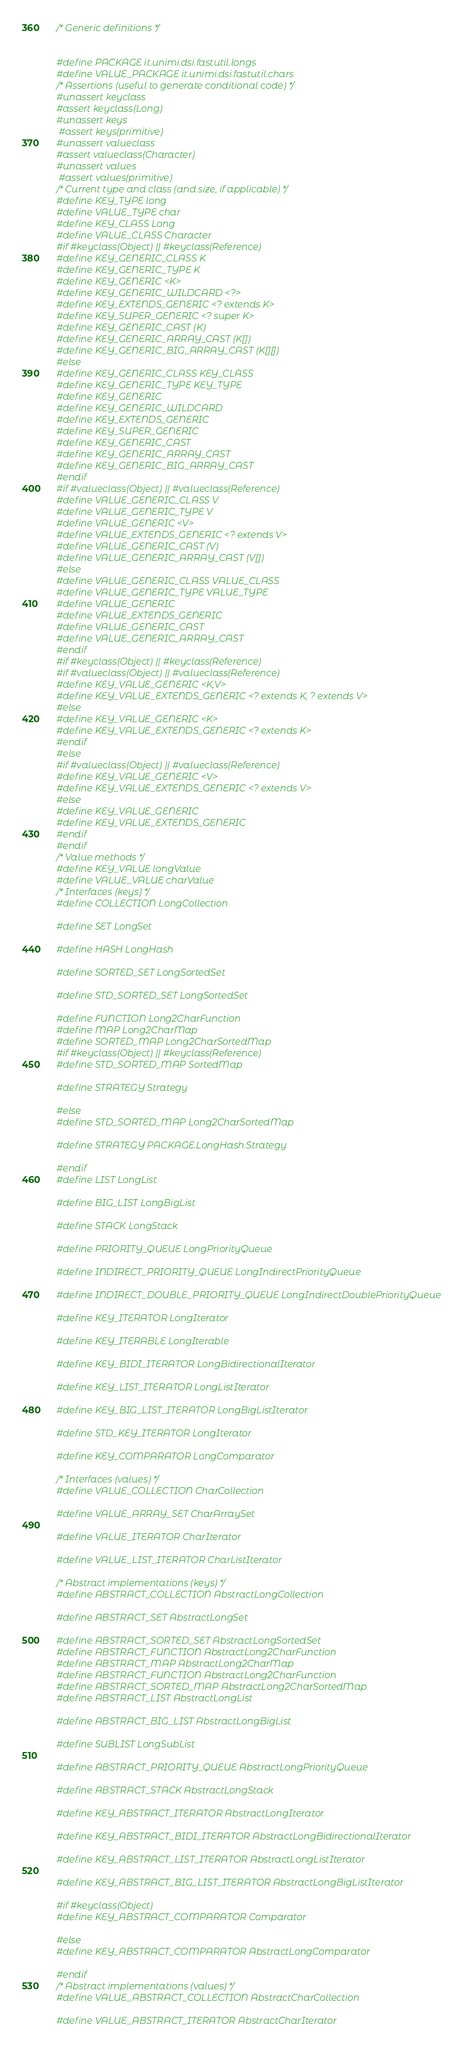<code> <loc_0><loc_0><loc_500><loc_500><_C_>/* Generic definitions */


#define PACKAGE it.unimi.dsi.fastutil.longs
#define VALUE_PACKAGE it.unimi.dsi.fastutil.chars
/* Assertions (useful to generate conditional code) */
#unassert keyclass
#assert keyclass(Long)
#unassert keys
 #assert keys(primitive)
#unassert valueclass
#assert valueclass(Character)
#unassert values
 #assert values(primitive)
/* Current type and class (and size, if applicable) */
#define KEY_TYPE long
#define VALUE_TYPE char
#define KEY_CLASS Long
#define VALUE_CLASS Character
#if #keyclass(Object) || #keyclass(Reference)
#define KEY_GENERIC_CLASS K
#define KEY_GENERIC_TYPE K
#define KEY_GENERIC <K>
#define KEY_GENERIC_WILDCARD <?>
#define KEY_EXTENDS_GENERIC <? extends K>
#define KEY_SUPER_GENERIC <? super K>
#define KEY_GENERIC_CAST (K)
#define KEY_GENERIC_ARRAY_CAST (K[])
#define KEY_GENERIC_BIG_ARRAY_CAST (K[][])
#else
#define KEY_GENERIC_CLASS KEY_CLASS
#define KEY_GENERIC_TYPE KEY_TYPE
#define KEY_GENERIC
#define KEY_GENERIC_WILDCARD
#define KEY_EXTENDS_GENERIC
#define KEY_SUPER_GENERIC
#define KEY_GENERIC_CAST
#define KEY_GENERIC_ARRAY_CAST
#define KEY_GENERIC_BIG_ARRAY_CAST
#endif
#if #valueclass(Object) || #valueclass(Reference)
#define VALUE_GENERIC_CLASS V
#define VALUE_GENERIC_TYPE V
#define VALUE_GENERIC <V>
#define VALUE_EXTENDS_GENERIC <? extends V>
#define VALUE_GENERIC_CAST (V)
#define VALUE_GENERIC_ARRAY_CAST (V[])
#else
#define VALUE_GENERIC_CLASS VALUE_CLASS
#define VALUE_GENERIC_TYPE VALUE_TYPE
#define VALUE_GENERIC
#define VALUE_EXTENDS_GENERIC
#define VALUE_GENERIC_CAST
#define VALUE_GENERIC_ARRAY_CAST
#endif
#if #keyclass(Object) || #keyclass(Reference)
#if #valueclass(Object) || #valueclass(Reference)
#define KEY_VALUE_GENERIC <K,V>
#define KEY_VALUE_EXTENDS_GENERIC <? extends K, ? extends V>
#else
#define KEY_VALUE_GENERIC <K>
#define KEY_VALUE_EXTENDS_GENERIC <? extends K>
#endif
#else
#if #valueclass(Object) || #valueclass(Reference)
#define KEY_VALUE_GENERIC <V>
#define KEY_VALUE_EXTENDS_GENERIC <? extends V>
#else
#define KEY_VALUE_GENERIC
#define KEY_VALUE_EXTENDS_GENERIC
#endif
#endif
/* Value methods */
#define KEY_VALUE longValue
#define VALUE_VALUE charValue
/* Interfaces (keys) */
#define COLLECTION LongCollection

#define SET LongSet

#define HASH LongHash

#define SORTED_SET LongSortedSet

#define STD_SORTED_SET LongSortedSet

#define FUNCTION Long2CharFunction
#define MAP Long2CharMap
#define SORTED_MAP Long2CharSortedMap
#if #keyclass(Object) || #keyclass(Reference)
#define STD_SORTED_MAP SortedMap

#define STRATEGY Strategy

#else
#define STD_SORTED_MAP Long2CharSortedMap

#define STRATEGY PACKAGE.LongHash.Strategy

#endif
#define LIST LongList

#define BIG_LIST LongBigList

#define STACK LongStack

#define PRIORITY_QUEUE LongPriorityQueue

#define INDIRECT_PRIORITY_QUEUE LongIndirectPriorityQueue

#define INDIRECT_DOUBLE_PRIORITY_QUEUE LongIndirectDoublePriorityQueue

#define KEY_ITERATOR LongIterator

#define KEY_ITERABLE LongIterable

#define KEY_BIDI_ITERATOR LongBidirectionalIterator

#define KEY_LIST_ITERATOR LongListIterator

#define KEY_BIG_LIST_ITERATOR LongBigListIterator

#define STD_KEY_ITERATOR LongIterator

#define KEY_COMPARATOR LongComparator

/* Interfaces (values) */
#define VALUE_COLLECTION CharCollection

#define VALUE_ARRAY_SET CharArraySet

#define VALUE_ITERATOR CharIterator

#define VALUE_LIST_ITERATOR CharListIterator

/* Abstract implementations (keys) */
#define ABSTRACT_COLLECTION AbstractLongCollection

#define ABSTRACT_SET AbstractLongSet

#define ABSTRACT_SORTED_SET AbstractLongSortedSet
#define ABSTRACT_FUNCTION AbstractLong2CharFunction
#define ABSTRACT_MAP AbstractLong2CharMap
#define ABSTRACT_FUNCTION AbstractLong2CharFunction
#define ABSTRACT_SORTED_MAP AbstractLong2CharSortedMap
#define ABSTRACT_LIST AbstractLongList

#define ABSTRACT_BIG_LIST AbstractLongBigList

#define SUBLIST LongSubList

#define ABSTRACT_PRIORITY_QUEUE AbstractLongPriorityQueue

#define ABSTRACT_STACK AbstractLongStack

#define KEY_ABSTRACT_ITERATOR AbstractLongIterator

#define KEY_ABSTRACT_BIDI_ITERATOR AbstractLongBidirectionalIterator

#define KEY_ABSTRACT_LIST_ITERATOR AbstractLongListIterator

#define KEY_ABSTRACT_BIG_LIST_ITERATOR AbstractLongBigListIterator

#if #keyclass(Object)
#define KEY_ABSTRACT_COMPARATOR Comparator

#else
#define KEY_ABSTRACT_COMPARATOR AbstractLongComparator

#endif
/* Abstract implementations (values) */
#define VALUE_ABSTRACT_COLLECTION AbstractCharCollection

#define VALUE_ABSTRACT_ITERATOR AbstractCharIterator
</code> 